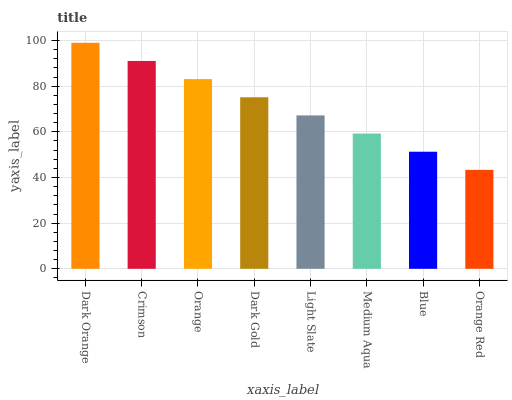Is Crimson the minimum?
Answer yes or no. No. Is Crimson the maximum?
Answer yes or no. No. Is Dark Orange greater than Crimson?
Answer yes or no. Yes. Is Crimson less than Dark Orange?
Answer yes or no. Yes. Is Crimson greater than Dark Orange?
Answer yes or no. No. Is Dark Orange less than Crimson?
Answer yes or no. No. Is Dark Gold the high median?
Answer yes or no. Yes. Is Light Slate the low median?
Answer yes or no. Yes. Is Light Slate the high median?
Answer yes or no. No. Is Blue the low median?
Answer yes or no. No. 